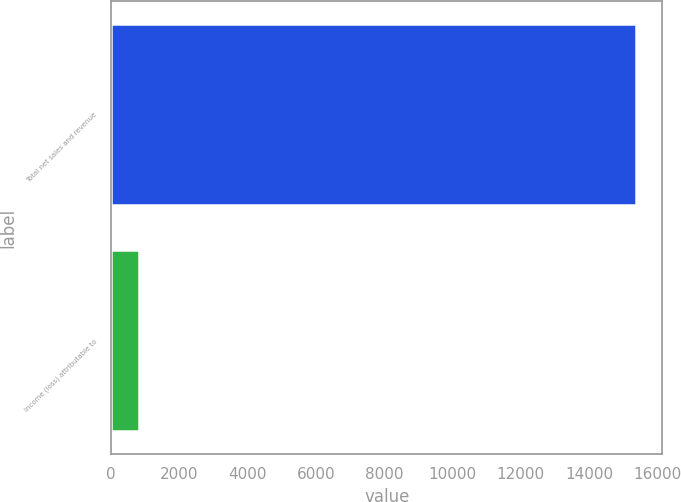Convert chart to OTSL. <chart><loc_0><loc_0><loc_500><loc_500><bar_chart><fcel>Total net sales and revenue<fcel>Income (loss) attributable to<nl><fcel>15379<fcel>818<nl></chart> 